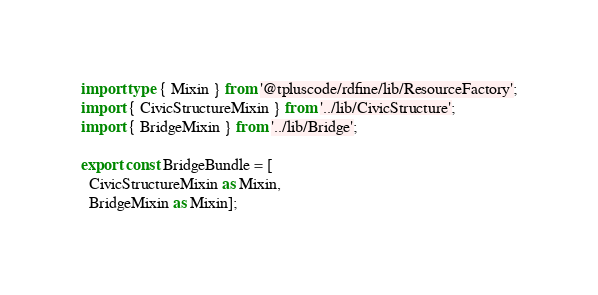Convert code to text. <code><loc_0><loc_0><loc_500><loc_500><_TypeScript_>import type { Mixin } from '@tpluscode/rdfine/lib/ResourceFactory';
import { CivicStructureMixin } from '../lib/CivicStructure';
import { BridgeMixin } from '../lib/Bridge';

export const BridgeBundle = [
  CivicStructureMixin as Mixin,
  BridgeMixin as Mixin];
</code> 